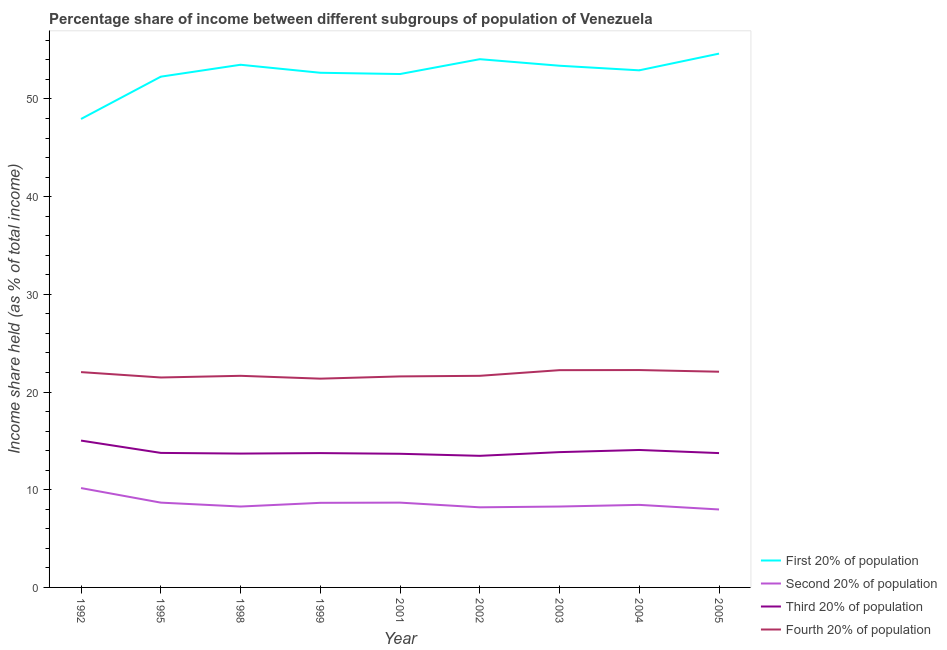How many different coloured lines are there?
Make the answer very short. 4. Does the line corresponding to share of the income held by second 20% of the population intersect with the line corresponding to share of the income held by fourth 20% of the population?
Ensure brevity in your answer.  No. What is the share of the income held by first 20% of the population in 1999?
Ensure brevity in your answer.  52.68. Across all years, what is the maximum share of the income held by fourth 20% of the population?
Ensure brevity in your answer.  22.25. Across all years, what is the minimum share of the income held by second 20% of the population?
Ensure brevity in your answer.  7.98. In which year was the share of the income held by fourth 20% of the population maximum?
Your answer should be compact. 2004. In which year was the share of the income held by fourth 20% of the population minimum?
Your answer should be very brief. 1999. What is the total share of the income held by second 20% of the population in the graph?
Make the answer very short. 77.38. What is the difference between the share of the income held by first 20% of the population in 1995 and that in 2003?
Provide a short and direct response. -1.12. What is the difference between the share of the income held by fourth 20% of the population in 1992 and the share of the income held by second 20% of the population in 2004?
Give a very brief answer. 13.59. What is the average share of the income held by first 20% of the population per year?
Keep it short and to the point. 52.67. In the year 2003, what is the difference between the share of the income held by second 20% of the population and share of the income held by first 20% of the population?
Provide a short and direct response. -45.12. In how many years, is the share of the income held by second 20% of the population greater than 34 %?
Offer a very short reply. 0. What is the ratio of the share of the income held by first 20% of the population in 2001 to that in 2003?
Offer a terse response. 0.98. What is the difference between the highest and the second highest share of the income held by first 20% of the population?
Your answer should be compact. 0.57. What is the difference between the highest and the lowest share of the income held by first 20% of the population?
Ensure brevity in your answer.  6.69. Is it the case that in every year, the sum of the share of the income held by first 20% of the population and share of the income held by fourth 20% of the population is greater than the sum of share of the income held by second 20% of the population and share of the income held by third 20% of the population?
Your answer should be very brief. Yes. Does the share of the income held by first 20% of the population monotonically increase over the years?
Your answer should be compact. No. Is the share of the income held by third 20% of the population strictly greater than the share of the income held by first 20% of the population over the years?
Your response must be concise. No. What is the difference between two consecutive major ticks on the Y-axis?
Ensure brevity in your answer.  10. Are the values on the major ticks of Y-axis written in scientific E-notation?
Your response must be concise. No. How are the legend labels stacked?
Provide a short and direct response. Vertical. What is the title of the graph?
Your answer should be very brief. Percentage share of income between different subgroups of population of Venezuela. Does "PFC gas" appear as one of the legend labels in the graph?
Your response must be concise. No. What is the label or title of the X-axis?
Your answer should be very brief. Year. What is the label or title of the Y-axis?
Offer a very short reply. Income share held (as % of total income). What is the Income share held (as % of total income) in First 20% of population in 1992?
Keep it short and to the point. 47.95. What is the Income share held (as % of total income) of Second 20% of population in 1992?
Your response must be concise. 10.17. What is the Income share held (as % of total income) of Third 20% of population in 1992?
Provide a succinct answer. 15.03. What is the Income share held (as % of total income) of Fourth 20% of population in 1992?
Keep it short and to the point. 22.04. What is the Income share held (as % of total income) in First 20% of population in 1995?
Offer a terse response. 52.28. What is the Income share held (as % of total income) of Second 20% of population in 1995?
Keep it short and to the point. 8.68. What is the Income share held (as % of total income) in Third 20% of population in 1995?
Provide a short and direct response. 13.77. What is the Income share held (as % of total income) of Fourth 20% of population in 1995?
Offer a very short reply. 21.49. What is the Income share held (as % of total income) of First 20% of population in 1998?
Your answer should be compact. 53.5. What is the Income share held (as % of total income) in Second 20% of population in 1998?
Make the answer very short. 8.28. What is the Income share held (as % of total income) of Third 20% of population in 1998?
Your response must be concise. 13.7. What is the Income share held (as % of total income) in Fourth 20% of population in 1998?
Keep it short and to the point. 21.66. What is the Income share held (as % of total income) of First 20% of population in 1999?
Give a very brief answer. 52.68. What is the Income share held (as % of total income) in Second 20% of population in 1999?
Provide a short and direct response. 8.66. What is the Income share held (as % of total income) in Third 20% of population in 1999?
Your response must be concise. 13.75. What is the Income share held (as % of total income) in Fourth 20% of population in 1999?
Provide a succinct answer. 21.37. What is the Income share held (as % of total income) in First 20% of population in 2001?
Your answer should be very brief. 52.55. What is the Income share held (as % of total income) in Second 20% of population in 2001?
Provide a succinct answer. 8.68. What is the Income share held (as % of total income) in Third 20% of population in 2001?
Your answer should be very brief. 13.68. What is the Income share held (as % of total income) in Fourth 20% of population in 2001?
Keep it short and to the point. 21.6. What is the Income share held (as % of total income) in First 20% of population in 2002?
Make the answer very short. 54.07. What is the Income share held (as % of total income) of Second 20% of population in 2002?
Your response must be concise. 8.2. What is the Income share held (as % of total income) of Third 20% of population in 2002?
Your response must be concise. 13.47. What is the Income share held (as % of total income) of Fourth 20% of population in 2002?
Provide a succinct answer. 21.66. What is the Income share held (as % of total income) in First 20% of population in 2003?
Your answer should be compact. 53.4. What is the Income share held (as % of total income) of Second 20% of population in 2003?
Your answer should be very brief. 8.28. What is the Income share held (as % of total income) of Third 20% of population in 2003?
Give a very brief answer. 13.85. What is the Income share held (as % of total income) of Fourth 20% of population in 2003?
Your response must be concise. 22.24. What is the Income share held (as % of total income) in First 20% of population in 2004?
Offer a terse response. 52.93. What is the Income share held (as % of total income) in Second 20% of population in 2004?
Your answer should be very brief. 8.45. What is the Income share held (as % of total income) of Third 20% of population in 2004?
Your answer should be very brief. 14.07. What is the Income share held (as % of total income) in Fourth 20% of population in 2004?
Ensure brevity in your answer.  22.25. What is the Income share held (as % of total income) of First 20% of population in 2005?
Offer a terse response. 54.64. What is the Income share held (as % of total income) in Second 20% of population in 2005?
Offer a very short reply. 7.98. What is the Income share held (as % of total income) in Third 20% of population in 2005?
Your answer should be very brief. 13.75. What is the Income share held (as % of total income) of Fourth 20% of population in 2005?
Ensure brevity in your answer.  22.08. Across all years, what is the maximum Income share held (as % of total income) in First 20% of population?
Your answer should be very brief. 54.64. Across all years, what is the maximum Income share held (as % of total income) in Second 20% of population?
Your response must be concise. 10.17. Across all years, what is the maximum Income share held (as % of total income) in Third 20% of population?
Your answer should be very brief. 15.03. Across all years, what is the maximum Income share held (as % of total income) of Fourth 20% of population?
Give a very brief answer. 22.25. Across all years, what is the minimum Income share held (as % of total income) in First 20% of population?
Keep it short and to the point. 47.95. Across all years, what is the minimum Income share held (as % of total income) of Second 20% of population?
Your answer should be very brief. 7.98. Across all years, what is the minimum Income share held (as % of total income) in Third 20% of population?
Provide a short and direct response. 13.47. Across all years, what is the minimum Income share held (as % of total income) in Fourth 20% of population?
Ensure brevity in your answer.  21.37. What is the total Income share held (as % of total income) in First 20% of population in the graph?
Offer a terse response. 474. What is the total Income share held (as % of total income) of Second 20% of population in the graph?
Your response must be concise. 77.38. What is the total Income share held (as % of total income) of Third 20% of population in the graph?
Provide a succinct answer. 125.07. What is the total Income share held (as % of total income) in Fourth 20% of population in the graph?
Provide a succinct answer. 196.39. What is the difference between the Income share held (as % of total income) of First 20% of population in 1992 and that in 1995?
Your response must be concise. -4.33. What is the difference between the Income share held (as % of total income) of Second 20% of population in 1992 and that in 1995?
Give a very brief answer. 1.49. What is the difference between the Income share held (as % of total income) in Third 20% of population in 1992 and that in 1995?
Offer a terse response. 1.26. What is the difference between the Income share held (as % of total income) in Fourth 20% of population in 1992 and that in 1995?
Give a very brief answer. 0.55. What is the difference between the Income share held (as % of total income) in First 20% of population in 1992 and that in 1998?
Make the answer very short. -5.55. What is the difference between the Income share held (as % of total income) of Second 20% of population in 1992 and that in 1998?
Provide a succinct answer. 1.89. What is the difference between the Income share held (as % of total income) of Third 20% of population in 1992 and that in 1998?
Keep it short and to the point. 1.33. What is the difference between the Income share held (as % of total income) in Fourth 20% of population in 1992 and that in 1998?
Provide a succinct answer. 0.38. What is the difference between the Income share held (as % of total income) of First 20% of population in 1992 and that in 1999?
Provide a succinct answer. -4.73. What is the difference between the Income share held (as % of total income) of Second 20% of population in 1992 and that in 1999?
Your response must be concise. 1.51. What is the difference between the Income share held (as % of total income) in Third 20% of population in 1992 and that in 1999?
Your answer should be very brief. 1.28. What is the difference between the Income share held (as % of total income) of Fourth 20% of population in 1992 and that in 1999?
Give a very brief answer. 0.67. What is the difference between the Income share held (as % of total income) of First 20% of population in 1992 and that in 2001?
Provide a short and direct response. -4.6. What is the difference between the Income share held (as % of total income) in Second 20% of population in 1992 and that in 2001?
Provide a short and direct response. 1.49. What is the difference between the Income share held (as % of total income) of Third 20% of population in 1992 and that in 2001?
Make the answer very short. 1.35. What is the difference between the Income share held (as % of total income) in Fourth 20% of population in 1992 and that in 2001?
Ensure brevity in your answer.  0.44. What is the difference between the Income share held (as % of total income) of First 20% of population in 1992 and that in 2002?
Your answer should be very brief. -6.12. What is the difference between the Income share held (as % of total income) of Second 20% of population in 1992 and that in 2002?
Offer a very short reply. 1.97. What is the difference between the Income share held (as % of total income) in Third 20% of population in 1992 and that in 2002?
Your answer should be compact. 1.56. What is the difference between the Income share held (as % of total income) of Fourth 20% of population in 1992 and that in 2002?
Provide a short and direct response. 0.38. What is the difference between the Income share held (as % of total income) of First 20% of population in 1992 and that in 2003?
Make the answer very short. -5.45. What is the difference between the Income share held (as % of total income) of Second 20% of population in 1992 and that in 2003?
Offer a very short reply. 1.89. What is the difference between the Income share held (as % of total income) in Third 20% of population in 1992 and that in 2003?
Offer a terse response. 1.18. What is the difference between the Income share held (as % of total income) of First 20% of population in 1992 and that in 2004?
Ensure brevity in your answer.  -4.98. What is the difference between the Income share held (as % of total income) of Second 20% of population in 1992 and that in 2004?
Offer a terse response. 1.72. What is the difference between the Income share held (as % of total income) in Fourth 20% of population in 1992 and that in 2004?
Give a very brief answer. -0.21. What is the difference between the Income share held (as % of total income) of First 20% of population in 1992 and that in 2005?
Provide a short and direct response. -6.69. What is the difference between the Income share held (as % of total income) in Second 20% of population in 1992 and that in 2005?
Your response must be concise. 2.19. What is the difference between the Income share held (as % of total income) in Third 20% of population in 1992 and that in 2005?
Offer a very short reply. 1.28. What is the difference between the Income share held (as % of total income) in Fourth 20% of population in 1992 and that in 2005?
Offer a very short reply. -0.04. What is the difference between the Income share held (as % of total income) in First 20% of population in 1995 and that in 1998?
Offer a terse response. -1.22. What is the difference between the Income share held (as % of total income) of Third 20% of population in 1995 and that in 1998?
Offer a very short reply. 0.07. What is the difference between the Income share held (as % of total income) of Fourth 20% of population in 1995 and that in 1998?
Your answer should be compact. -0.17. What is the difference between the Income share held (as % of total income) of First 20% of population in 1995 and that in 1999?
Offer a terse response. -0.4. What is the difference between the Income share held (as % of total income) of Third 20% of population in 1995 and that in 1999?
Your answer should be compact. 0.02. What is the difference between the Income share held (as % of total income) of Fourth 20% of population in 1995 and that in 1999?
Ensure brevity in your answer.  0.12. What is the difference between the Income share held (as % of total income) of First 20% of population in 1995 and that in 2001?
Make the answer very short. -0.27. What is the difference between the Income share held (as % of total income) in Third 20% of population in 1995 and that in 2001?
Offer a very short reply. 0.09. What is the difference between the Income share held (as % of total income) of Fourth 20% of population in 1995 and that in 2001?
Offer a very short reply. -0.11. What is the difference between the Income share held (as % of total income) in First 20% of population in 1995 and that in 2002?
Keep it short and to the point. -1.79. What is the difference between the Income share held (as % of total income) of Second 20% of population in 1995 and that in 2002?
Give a very brief answer. 0.48. What is the difference between the Income share held (as % of total income) of Third 20% of population in 1995 and that in 2002?
Your answer should be very brief. 0.3. What is the difference between the Income share held (as % of total income) of Fourth 20% of population in 1995 and that in 2002?
Offer a very short reply. -0.17. What is the difference between the Income share held (as % of total income) in First 20% of population in 1995 and that in 2003?
Your answer should be compact. -1.12. What is the difference between the Income share held (as % of total income) in Third 20% of population in 1995 and that in 2003?
Make the answer very short. -0.08. What is the difference between the Income share held (as % of total income) of Fourth 20% of population in 1995 and that in 2003?
Offer a terse response. -0.75. What is the difference between the Income share held (as % of total income) in First 20% of population in 1995 and that in 2004?
Ensure brevity in your answer.  -0.65. What is the difference between the Income share held (as % of total income) of Second 20% of population in 1995 and that in 2004?
Provide a succinct answer. 0.23. What is the difference between the Income share held (as % of total income) in Third 20% of population in 1995 and that in 2004?
Keep it short and to the point. -0.3. What is the difference between the Income share held (as % of total income) of Fourth 20% of population in 1995 and that in 2004?
Give a very brief answer. -0.76. What is the difference between the Income share held (as % of total income) of First 20% of population in 1995 and that in 2005?
Offer a terse response. -2.36. What is the difference between the Income share held (as % of total income) of Fourth 20% of population in 1995 and that in 2005?
Your answer should be compact. -0.59. What is the difference between the Income share held (as % of total income) of First 20% of population in 1998 and that in 1999?
Ensure brevity in your answer.  0.82. What is the difference between the Income share held (as % of total income) in Second 20% of population in 1998 and that in 1999?
Offer a terse response. -0.38. What is the difference between the Income share held (as % of total income) in Third 20% of population in 1998 and that in 1999?
Give a very brief answer. -0.05. What is the difference between the Income share held (as % of total income) of Fourth 20% of population in 1998 and that in 1999?
Your response must be concise. 0.29. What is the difference between the Income share held (as % of total income) in First 20% of population in 1998 and that in 2001?
Your answer should be very brief. 0.95. What is the difference between the Income share held (as % of total income) of Second 20% of population in 1998 and that in 2001?
Ensure brevity in your answer.  -0.4. What is the difference between the Income share held (as % of total income) in Third 20% of population in 1998 and that in 2001?
Provide a succinct answer. 0.02. What is the difference between the Income share held (as % of total income) in First 20% of population in 1998 and that in 2002?
Offer a terse response. -0.57. What is the difference between the Income share held (as % of total income) of Second 20% of population in 1998 and that in 2002?
Your answer should be compact. 0.08. What is the difference between the Income share held (as % of total income) of Third 20% of population in 1998 and that in 2002?
Your answer should be very brief. 0.23. What is the difference between the Income share held (as % of total income) of Third 20% of population in 1998 and that in 2003?
Give a very brief answer. -0.15. What is the difference between the Income share held (as % of total income) in Fourth 20% of population in 1998 and that in 2003?
Keep it short and to the point. -0.58. What is the difference between the Income share held (as % of total income) of First 20% of population in 1998 and that in 2004?
Provide a succinct answer. 0.57. What is the difference between the Income share held (as % of total income) in Second 20% of population in 1998 and that in 2004?
Offer a terse response. -0.17. What is the difference between the Income share held (as % of total income) of Third 20% of population in 1998 and that in 2004?
Offer a terse response. -0.37. What is the difference between the Income share held (as % of total income) in Fourth 20% of population in 1998 and that in 2004?
Keep it short and to the point. -0.59. What is the difference between the Income share held (as % of total income) in First 20% of population in 1998 and that in 2005?
Offer a very short reply. -1.14. What is the difference between the Income share held (as % of total income) in Second 20% of population in 1998 and that in 2005?
Provide a succinct answer. 0.3. What is the difference between the Income share held (as % of total income) in Third 20% of population in 1998 and that in 2005?
Give a very brief answer. -0.05. What is the difference between the Income share held (as % of total income) of Fourth 20% of population in 1998 and that in 2005?
Your response must be concise. -0.42. What is the difference between the Income share held (as % of total income) of First 20% of population in 1999 and that in 2001?
Your answer should be very brief. 0.13. What is the difference between the Income share held (as % of total income) in Second 20% of population in 1999 and that in 2001?
Make the answer very short. -0.02. What is the difference between the Income share held (as % of total income) of Third 20% of population in 1999 and that in 2001?
Keep it short and to the point. 0.07. What is the difference between the Income share held (as % of total income) of Fourth 20% of population in 1999 and that in 2001?
Give a very brief answer. -0.23. What is the difference between the Income share held (as % of total income) of First 20% of population in 1999 and that in 2002?
Your answer should be compact. -1.39. What is the difference between the Income share held (as % of total income) in Second 20% of population in 1999 and that in 2002?
Provide a short and direct response. 0.46. What is the difference between the Income share held (as % of total income) in Third 20% of population in 1999 and that in 2002?
Make the answer very short. 0.28. What is the difference between the Income share held (as % of total income) of Fourth 20% of population in 1999 and that in 2002?
Your answer should be very brief. -0.29. What is the difference between the Income share held (as % of total income) in First 20% of population in 1999 and that in 2003?
Provide a short and direct response. -0.72. What is the difference between the Income share held (as % of total income) of Second 20% of population in 1999 and that in 2003?
Your answer should be compact. 0.38. What is the difference between the Income share held (as % of total income) of Fourth 20% of population in 1999 and that in 2003?
Ensure brevity in your answer.  -0.87. What is the difference between the Income share held (as % of total income) of First 20% of population in 1999 and that in 2004?
Your response must be concise. -0.25. What is the difference between the Income share held (as % of total income) of Second 20% of population in 1999 and that in 2004?
Give a very brief answer. 0.21. What is the difference between the Income share held (as % of total income) of Third 20% of population in 1999 and that in 2004?
Make the answer very short. -0.32. What is the difference between the Income share held (as % of total income) in Fourth 20% of population in 1999 and that in 2004?
Provide a short and direct response. -0.88. What is the difference between the Income share held (as % of total income) of First 20% of population in 1999 and that in 2005?
Give a very brief answer. -1.96. What is the difference between the Income share held (as % of total income) in Second 20% of population in 1999 and that in 2005?
Provide a short and direct response. 0.68. What is the difference between the Income share held (as % of total income) in Third 20% of population in 1999 and that in 2005?
Give a very brief answer. 0. What is the difference between the Income share held (as % of total income) of Fourth 20% of population in 1999 and that in 2005?
Offer a terse response. -0.71. What is the difference between the Income share held (as % of total income) in First 20% of population in 2001 and that in 2002?
Provide a short and direct response. -1.52. What is the difference between the Income share held (as % of total income) of Second 20% of population in 2001 and that in 2002?
Provide a succinct answer. 0.48. What is the difference between the Income share held (as % of total income) in Third 20% of population in 2001 and that in 2002?
Make the answer very short. 0.21. What is the difference between the Income share held (as % of total income) of Fourth 20% of population in 2001 and that in 2002?
Offer a terse response. -0.06. What is the difference between the Income share held (as % of total income) in First 20% of population in 2001 and that in 2003?
Give a very brief answer. -0.85. What is the difference between the Income share held (as % of total income) in Second 20% of population in 2001 and that in 2003?
Your answer should be compact. 0.4. What is the difference between the Income share held (as % of total income) of Third 20% of population in 2001 and that in 2003?
Ensure brevity in your answer.  -0.17. What is the difference between the Income share held (as % of total income) in Fourth 20% of population in 2001 and that in 2003?
Your answer should be compact. -0.64. What is the difference between the Income share held (as % of total income) in First 20% of population in 2001 and that in 2004?
Provide a succinct answer. -0.38. What is the difference between the Income share held (as % of total income) in Second 20% of population in 2001 and that in 2004?
Keep it short and to the point. 0.23. What is the difference between the Income share held (as % of total income) in Third 20% of population in 2001 and that in 2004?
Your response must be concise. -0.39. What is the difference between the Income share held (as % of total income) in Fourth 20% of population in 2001 and that in 2004?
Your answer should be compact. -0.65. What is the difference between the Income share held (as % of total income) of First 20% of population in 2001 and that in 2005?
Offer a terse response. -2.09. What is the difference between the Income share held (as % of total income) in Third 20% of population in 2001 and that in 2005?
Offer a very short reply. -0.07. What is the difference between the Income share held (as % of total income) of Fourth 20% of population in 2001 and that in 2005?
Your answer should be compact. -0.48. What is the difference between the Income share held (as % of total income) in First 20% of population in 2002 and that in 2003?
Keep it short and to the point. 0.67. What is the difference between the Income share held (as % of total income) of Second 20% of population in 2002 and that in 2003?
Give a very brief answer. -0.08. What is the difference between the Income share held (as % of total income) of Third 20% of population in 2002 and that in 2003?
Your response must be concise. -0.38. What is the difference between the Income share held (as % of total income) of Fourth 20% of population in 2002 and that in 2003?
Provide a succinct answer. -0.58. What is the difference between the Income share held (as % of total income) in First 20% of population in 2002 and that in 2004?
Offer a terse response. 1.14. What is the difference between the Income share held (as % of total income) in Third 20% of population in 2002 and that in 2004?
Provide a short and direct response. -0.6. What is the difference between the Income share held (as % of total income) in Fourth 20% of population in 2002 and that in 2004?
Provide a short and direct response. -0.59. What is the difference between the Income share held (as % of total income) of First 20% of population in 2002 and that in 2005?
Provide a succinct answer. -0.57. What is the difference between the Income share held (as % of total income) in Second 20% of population in 2002 and that in 2005?
Offer a very short reply. 0.22. What is the difference between the Income share held (as % of total income) in Third 20% of population in 2002 and that in 2005?
Give a very brief answer. -0.28. What is the difference between the Income share held (as % of total income) in Fourth 20% of population in 2002 and that in 2005?
Provide a succinct answer. -0.42. What is the difference between the Income share held (as % of total income) in First 20% of population in 2003 and that in 2004?
Offer a terse response. 0.47. What is the difference between the Income share held (as % of total income) in Second 20% of population in 2003 and that in 2004?
Your answer should be compact. -0.17. What is the difference between the Income share held (as % of total income) in Third 20% of population in 2003 and that in 2004?
Provide a short and direct response. -0.22. What is the difference between the Income share held (as % of total income) in Fourth 20% of population in 2003 and that in 2004?
Your response must be concise. -0.01. What is the difference between the Income share held (as % of total income) in First 20% of population in 2003 and that in 2005?
Ensure brevity in your answer.  -1.24. What is the difference between the Income share held (as % of total income) in Fourth 20% of population in 2003 and that in 2005?
Provide a short and direct response. 0.16. What is the difference between the Income share held (as % of total income) in First 20% of population in 2004 and that in 2005?
Your answer should be very brief. -1.71. What is the difference between the Income share held (as % of total income) of Second 20% of population in 2004 and that in 2005?
Ensure brevity in your answer.  0.47. What is the difference between the Income share held (as % of total income) in Third 20% of population in 2004 and that in 2005?
Provide a succinct answer. 0.32. What is the difference between the Income share held (as % of total income) of Fourth 20% of population in 2004 and that in 2005?
Offer a terse response. 0.17. What is the difference between the Income share held (as % of total income) of First 20% of population in 1992 and the Income share held (as % of total income) of Second 20% of population in 1995?
Make the answer very short. 39.27. What is the difference between the Income share held (as % of total income) in First 20% of population in 1992 and the Income share held (as % of total income) in Third 20% of population in 1995?
Offer a terse response. 34.18. What is the difference between the Income share held (as % of total income) in First 20% of population in 1992 and the Income share held (as % of total income) in Fourth 20% of population in 1995?
Provide a short and direct response. 26.46. What is the difference between the Income share held (as % of total income) in Second 20% of population in 1992 and the Income share held (as % of total income) in Fourth 20% of population in 1995?
Offer a very short reply. -11.32. What is the difference between the Income share held (as % of total income) of Third 20% of population in 1992 and the Income share held (as % of total income) of Fourth 20% of population in 1995?
Your answer should be compact. -6.46. What is the difference between the Income share held (as % of total income) of First 20% of population in 1992 and the Income share held (as % of total income) of Second 20% of population in 1998?
Make the answer very short. 39.67. What is the difference between the Income share held (as % of total income) of First 20% of population in 1992 and the Income share held (as % of total income) of Third 20% of population in 1998?
Keep it short and to the point. 34.25. What is the difference between the Income share held (as % of total income) in First 20% of population in 1992 and the Income share held (as % of total income) in Fourth 20% of population in 1998?
Provide a short and direct response. 26.29. What is the difference between the Income share held (as % of total income) in Second 20% of population in 1992 and the Income share held (as % of total income) in Third 20% of population in 1998?
Keep it short and to the point. -3.53. What is the difference between the Income share held (as % of total income) of Second 20% of population in 1992 and the Income share held (as % of total income) of Fourth 20% of population in 1998?
Ensure brevity in your answer.  -11.49. What is the difference between the Income share held (as % of total income) of Third 20% of population in 1992 and the Income share held (as % of total income) of Fourth 20% of population in 1998?
Keep it short and to the point. -6.63. What is the difference between the Income share held (as % of total income) in First 20% of population in 1992 and the Income share held (as % of total income) in Second 20% of population in 1999?
Ensure brevity in your answer.  39.29. What is the difference between the Income share held (as % of total income) in First 20% of population in 1992 and the Income share held (as % of total income) in Third 20% of population in 1999?
Offer a terse response. 34.2. What is the difference between the Income share held (as % of total income) in First 20% of population in 1992 and the Income share held (as % of total income) in Fourth 20% of population in 1999?
Ensure brevity in your answer.  26.58. What is the difference between the Income share held (as % of total income) in Second 20% of population in 1992 and the Income share held (as % of total income) in Third 20% of population in 1999?
Your answer should be very brief. -3.58. What is the difference between the Income share held (as % of total income) of Second 20% of population in 1992 and the Income share held (as % of total income) of Fourth 20% of population in 1999?
Keep it short and to the point. -11.2. What is the difference between the Income share held (as % of total income) of Third 20% of population in 1992 and the Income share held (as % of total income) of Fourth 20% of population in 1999?
Offer a terse response. -6.34. What is the difference between the Income share held (as % of total income) in First 20% of population in 1992 and the Income share held (as % of total income) in Second 20% of population in 2001?
Offer a terse response. 39.27. What is the difference between the Income share held (as % of total income) in First 20% of population in 1992 and the Income share held (as % of total income) in Third 20% of population in 2001?
Ensure brevity in your answer.  34.27. What is the difference between the Income share held (as % of total income) of First 20% of population in 1992 and the Income share held (as % of total income) of Fourth 20% of population in 2001?
Give a very brief answer. 26.35. What is the difference between the Income share held (as % of total income) of Second 20% of population in 1992 and the Income share held (as % of total income) of Third 20% of population in 2001?
Your response must be concise. -3.51. What is the difference between the Income share held (as % of total income) in Second 20% of population in 1992 and the Income share held (as % of total income) in Fourth 20% of population in 2001?
Keep it short and to the point. -11.43. What is the difference between the Income share held (as % of total income) of Third 20% of population in 1992 and the Income share held (as % of total income) of Fourth 20% of population in 2001?
Your answer should be very brief. -6.57. What is the difference between the Income share held (as % of total income) in First 20% of population in 1992 and the Income share held (as % of total income) in Second 20% of population in 2002?
Ensure brevity in your answer.  39.75. What is the difference between the Income share held (as % of total income) in First 20% of population in 1992 and the Income share held (as % of total income) in Third 20% of population in 2002?
Ensure brevity in your answer.  34.48. What is the difference between the Income share held (as % of total income) in First 20% of population in 1992 and the Income share held (as % of total income) in Fourth 20% of population in 2002?
Provide a short and direct response. 26.29. What is the difference between the Income share held (as % of total income) in Second 20% of population in 1992 and the Income share held (as % of total income) in Third 20% of population in 2002?
Give a very brief answer. -3.3. What is the difference between the Income share held (as % of total income) in Second 20% of population in 1992 and the Income share held (as % of total income) in Fourth 20% of population in 2002?
Offer a very short reply. -11.49. What is the difference between the Income share held (as % of total income) of Third 20% of population in 1992 and the Income share held (as % of total income) of Fourth 20% of population in 2002?
Provide a succinct answer. -6.63. What is the difference between the Income share held (as % of total income) of First 20% of population in 1992 and the Income share held (as % of total income) of Second 20% of population in 2003?
Provide a succinct answer. 39.67. What is the difference between the Income share held (as % of total income) of First 20% of population in 1992 and the Income share held (as % of total income) of Third 20% of population in 2003?
Your response must be concise. 34.1. What is the difference between the Income share held (as % of total income) of First 20% of population in 1992 and the Income share held (as % of total income) of Fourth 20% of population in 2003?
Your answer should be very brief. 25.71. What is the difference between the Income share held (as % of total income) of Second 20% of population in 1992 and the Income share held (as % of total income) of Third 20% of population in 2003?
Your answer should be very brief. -3.68. What is the difference between the Income share held (as % of total income) in Second 20% of population in 1992 and the Income share held (as % of total income) in Fourth 20% of population in 2003?
Your answer should be compact. -12.07. What is the difference between the Income share held (as % of total income) in Third 20% of population in 1992 and the Income share held (as % of total income) in Fourth 20% of population in 2003?
Ensure brevity in your answer.  -7.21. What is the difference between the Income share held (as % of total income) in First 20% of population in 1992 and the Income share held (as % of total income) in Second 20% of population in 2004?
Offer a very short reply. 39.5. What is the difference between the Income share held (as % of total income) in First 20% of population in 1992 and the Income share held (as % of total income) in Third 20% of population in 2004?
Keep it short and to the point. 33.88. What is the difference between the Income share held (as % of total income) in First 20% of population in 1992 and the Income share held (as % of total income) in Fourth 20% of population in 2004?
Make the answer very short. 25.7. What is the difference between the Income share held (as % of total income) in Second 20% of population in 1992 and the Income share held (as % of total income) in Third 20% of population in 2004?
Keep it short and to the point. -3.9. What is the difference between the Income share held (as % of total income) in Second 20% of population in 1992 and the Income share held (as % of total income) in Fourth 20% of population in 2004?
Your answer should be compact. -12.08. What is the difference between the Income share held (as % of total income) in Third 20% of population in 1992 and the Income share held (as % of total income) in Fourth 20% of population in 2004?
Your answer should be very brief. -7.22. What is the difference between the Income share held (as % of total income) of First 20% of population in 1992 and the Income share held (as % of total income) of Second 20% of population in 2005?
Your answer should be compact. 39.97. What is the difference between the Income share held (as % of total income) in First 20% of population in 1992 and the Income share held (as % of total income) in Third 20% of population in 2005?
Offer a terse response. 34.2. What is the difference between the Income share held (as % of total income) in First 20% of population in 1992 and the Income share held (as % of total income) in Fourth 20% of population in 2005?
Keep it short and to the point. 25.87. What is the difference between the Income share held (as % of total income) in Second 20% of population in 1992 and the Income share held (as % of total income) in Third 20% of population in 2005?
Give a very brief answer. -3.58. What is the difference between the Income share held (as % of total income) in Second 20% of population in 1992 and the Income share held (as % of total income) in Fourth 20% of population in 2005?
Your answer should be compact. -11.91. What is the difference between the Income share held (as % of total income) in Third 20% of population in 1992 and the Income share held (as % of total income) in Fourth 20% of population in 2005?
Ensure brevity in your answer.  -7.05. What is the difference between the Income share held (as % of total income) in First 20% of population in 1995 and the Income share held (as % of total income) in Second 20% of population in 1998?
Make the answer very short. 44. What is the difference between the Income share held (as % of total income) of First 20% of population in 1995 and the Income share held (as % of total income) of Third 20% of population in 1998?
Offer a terse response. 38.58. What is the difference between the Income share held (as % of total income) of First 20% of population in 1995 and the Income share held (as % of total income) of Fourth 20% of population in 1998?
Make the answer very short. 30.62. What is the difference between the Income share held (as % of total income) of Second 20% of population in 1995 and the Income share held (as % of total income) of Third 20% of population in 1998?
Give a very brief answer. -5.02. What is the difference between the Income share held (as % of total income) in Second 20% of population in 1995 and the Income share held (as % of total income) in Fourth 20% of population in 1998?
Offer a very short reply. -12.98. What is the difference between the Income share held (as % of total income) of Third 20% of population in 1995 and the Income share held (as % of total income) of Fourth 20% of population in 1998?
Ensure brevity in your answer.  -7.89. What is the difference between the Income share held (as % of total income) of First 20% of population in 1995 and the Income share held (as % of total income) of Second 20% of population in 1999?
Keep it short and to the point. 43.62. What is the difference between the Income share held (as % of total income) of First 20% of population in 1995 and the Income share held (as % of total income) of Third 20% of population in 1999?
Offer a very short reply. 38.53. What is the difference between the Income share held (as % of total income) of First 20% of population in 1995 and the Income share held (as % of total income) of Fourth 20% of population in 1999?
Give a very brief answer. 30.91. What is the difference between the Income share held (as % of total income) in Second 20% of population in 1995 and the Income share held (as % of total income) in Third 20% of population in 1999?
Give a very brief answer. -5.07. What is the difference between the Income share held (as % of total income) of Second 20% of population in 1995 and the Income share held (as % of total income) of Fourth 20% of population in 1999?
Give a very brief answer. -12.69. What is the difference between the Income share held (as % of total income) in First 20% of population in 1995 and the Income share held (as % of total income) in Second 20% of population in 2001?
Your response must be concise. 43.6. What is the difference between the Income share held (as % of total income) in First 20% of population in 1995 and the Income share held (as % of total income) in Third 20% of population in 2001?
Give a very brief answer. 38.6. What is the difference between the Income share held (as % of total income) of First 20% of population in 1995 and the Income share held (as % of total income) of Fourth 20% of population in 2001?
Make the answer very short. 30.68. What is the difference between the Income share held (as % of total income) in Second 20% of population in 1995 and the Income share held (as % of total income) in Fourth 20% of population in 2001?
Offer a very short reply. -12.92. What is the difference between the Income share held (as % of total income) in Third 20% of population in 1995 and the Income share held (as % of total income) in Fourth 20% of population in 2001?
Provide a short and direct response. -7.83. What is the difference between the Income share held (as % of total income) of First 20% of population in 1995 and the Income share held (as % of total income) of Second 20% of population in 2002?
Make the answer very short. 44.08. What is the difference between the Income share held (as % of total income) in First 20% of population in 1995 and the Income share held (as % of total income) in Third 20% of population in 2002?
Give a very brief answer. 38.81. What is the difference between the Income share held (as % of total income) of First 20% of population in 1995 and the Income share held (as % of total income) of Fourth 20% of population in 2002?
Provide a succinct answer. 30.62. What is the difference between the Income share held (as % of total income) in Second 20% of population in 1995 and the Income share held (as % of total income) in Third 20% of population in 2002?
Provide a succinct answer. -4.79. What is the difference between the Income share held (as % of total income) in Second 20% of population in 1995 and the Income share held (as % of total income) in Fourth 20% of population in 2002?
Provide a succinct answer. -12.98. What is the difference between the Income share held (as % of total income) of Third 20% of population in 1995 and the Income share held (as % of total income) of Fourth 20% of population in 2002?
Ensure brevity in your answer.  -7.89. What is the difference between the Income share held (as % of total income) in First 20% of population in 1995 and the Income share held (as % of total income) in Second 20% of population in 2003?
Make the answer very short. 44. What is the difference between the Income share held (as % of total income) in First 20% of population in 1995 and the Income share held (as % of total income) in Third 20% of population in 2003?
Ensure brevity in your answer.  38.43. What is the difference between the Income share held (as % of total income) of First 20% of population in 1995 and the Income share held (as % of total income) of Fourth 20% of population in 2003?
Keep it short and to the point. 30.04. What is the difference between the Income share held (as % of total income) in Second 20% of population in 1995 and the Income share held (as % of total income) in Third 20% of population in 2003?
Keep it short and to the point. -5.17. What is the difference between the Income share held (as % of total income) in Second 20% of population in 1995 and the Income share held (as % of total income) in Fourth 20% of population in 2003?
Your answer should be compact. -13.56. What is the difference between the Income share held (as % of total income) of Third 20% of population in 1995 and the Income share held (as % of total income) of Fourth 20% of population in 2003?
Provide a succinct answer. -8.47. What is the difference between the Income share held (as % of total income) in First 20% of population in 1995 and the Income share held (as % of total income) in Second 20% of population in 2004?
Give a very brief answer. 43.83. What is the difference between the Income share held (as % of total income) in First 20% of population in 1995 and the Income share held (as % of total income) in Third 20% of population in 2004?
Offer a terse response. 38.21. What is the difference between the Income share held (as % of total income) of First 20% of population in 1995 and the Income share held (as % of total income) of Fourth 20% of population in 2004?
Your response must be concise. 30.03. What is the difference between the Income share held (as % of total income) of Second 20% of population in 1995 and the Income share held (as % of total income) of Third 20% of population in 2004?
Provide a succinct answer. -5.39. What is the difference between the Income share held (as % of total income) of Second 20% of population in 1995 and the Income share held (as % of total income) of Fourth 20% of population in 2004?
Make the answer very short. -13.57. What is the difference between the Income share held (as % of total income) in Third 20% of population in 1995 and the Income share held (as % of total income) in Fourth 20% of population in 2004?
Your answer should be compact. -8.48. What is the difference between the Income share held (as % of total income) in First 20% of population in 1995 and the Income share held (as % of total income) in Second 20% of population in 2005?
Keep it short and to the point. 44.3. What is the difference between the Income share held (as % of total income) of First 20% of population in 1995 and the Income share held (as % of total income) of Third 20% of population in 2005?
Make the answer very short. 38.53. What is the difference between the Income share held (as % of total income) in First 20% of population in 1995 and the Income share held (as % of total income) in Fourth 20% of population in 2005?
Ensure brevity in your answer.  30.2. What is the difference between the Income share held (as % of total income) of Second 20% of population in 1995 and the Income share held (as % of total income) of Third 20% of population in 2005?
Offer a terse response. -5.07. What is the difference between the Income share held (as % of total income) of Third 20% of population in 1995 and the Income share held (as % of total income) of Fourth 20% of population in 2005?
Your answer should be compact. -8.31. What is the difference between the Income share held (as % of total income) of First 20% of population in 1998 and the Income share held (as % of total income) of Second 20% of population in 1999?
Ensure brevity in your answer.  44.84. What is the difference between the Income share held (as % of total income) of First 20% of population in 1998 and the Income share held (as % of total income) of Third 20% of population in 1999?
Give a very brief answer. 39.75. What is the difference between the Income share held (as % of total income) of First 20% of population in 1998 and the Income share held (as % of total income) of Fourth 20% of population in 1999?
Give a very brief answer. 32.13. What is the difference between the Income share held (as % of total income) in Second 20% of population in 1998 and the Income share held (as % of total income) in Third 20% of population in 1999?
Offer a very short reply. -5.47. What is the difference between the Income share held (as % of total income) in Second 20% of population in 1998 and the Income share held (as % of total income) in Fourth 20% of population in 1999?
Make the answer very short. -13.09. What is the difference between the Income share held (as % of total income) of Third 20% of population in 1998 and the Income share held (as % of total income) of Fourth 20% of population in 1999?
Give a very brief answer. -7.67. What is the difference between the Income share held (as % of total income) in First 20% of population in 1998 and the Income share held (as % of total income) in Second 20% of population in 2001?
Keep it short and to the point. 44.82. What is the difference between the Income share held (as % of total income) of First 20% of population in 1998 and the Income share held (as % of total income) of Third 20% of population in 2001?
Your response must be concise. 39.82. What is the difference between the Income share held (as % of total income) in First 20% of population in 1998 and the Income share held (as % of total income) in Fourth 20% of population in 2001?
Keep it short and to the point. 31.9. What is the difference between the Income share held (as % of total income) in Second 20% of population in 1998 and the Income share held (as % of total income) in Fourth 20% of population in 2001?
Ensure brevity in your answer.  -13.32. What is the difference between the Income share held (as % of total income) in Third 20% of population in 1998 and the Income share held (as % of total income) in Fourth 20% of population in 2001?
Provide a short and direct response. -7.9. What is the difference between the Income share held (as % of total income) in First 20% of population in 1998 and the Income share held (as % of total income) in Second 20% of population in 2002?
Offer a terse response. 45.3. What is the difference between the Income share held (as % of total income) of First 20% of population in 1998 and the Income share held (as % of total income) of Third 20% of population in 2002?
Make the answer very short. 40.03. What is the difference between the Income share held (as % of total income) in First 20% of population in 1998 and the Income share held (as % of total income) in Fourth 20% of population in 2002?
Your answer should be very brief. 31.84. What is the difference between the Income share held (as % of total income) in Second 20% of population in 1998 and the Income share held (as % of total income) in Third 20% of population in 2002?
Keep it short and to the point. -5.19. What is the difference between the Income share held (as % of total income) of Second 20% of population in 1998 and the Income share held (as % of total income) of Fourth 20% of population in 2002?
Make the answer very short. -13.38. What is the difference between the Income share held (as % of total income) of Third 20% of population in 1998 and the Income share held (as % of total income) of Fourth 20% of population in 2002?
Your response must be concise. -7.96. What is the difference between the Income share held (as % of total income) in First 20% of population in 1998 and the Income share held (as % of total income) in Second 20% of population in 2003?
Keep it short and to the point. 45.22. What is the difference between the Income share held (as % of total income) in First 20% of population in 1998 and the Income share held (as % of total income) in Third 20% of population in 2003?
Give a very brief answer. 39.65. What is the difference between the Income share held (as % of total income) in First 20% of population in 1998 and the Income share held (as % of total income) in Fourth 20% of population in 2003?
Keep it short and to the point. 31.26. What is the difference between the Income share held (as % of total income) in Second 20% of population in 1998 and the Income share held (as % of total income) in Third 20% of population in 2003?
Provide a short and direct response. -5.57. What is the difference between the Income share held (as % of total income) in Second 20% of population in 1998 and the Income share held (as % of total income) in Fourth 20% of population in 2003?
Your response must be concise. -13.96. What is the difference between the Income share held (as % of total income) of Third 20% of population in 1998 and the Income share held (as % of total income) of Fourth 20% of population in 2003?
Ensure brevity in your answer.  -8.54. What is the difference between the Income share held (as % of total income) of First 20% of population in 1998 and the Income share held (as % of total income) of Second 20% of population in 2004?
Ensure brevity in your answer.  45.05. What is the difference between the Income share held (as % of total income) of First 20% of population in 1998 and the Income share held (as % of total income) of Third 20% of population in 2004?
Provide a short and direct response. 39.43. What is the difference between the Income share held (as % of total income) of First 20% of population in 1998 and the Income share held (as % of total income) of Fourth 20% of population in 2004?
Make the answer very short. 31.25. What is the difference between the Income share held (as % of total income) in Second 20% of population in 1998 and the Income share held (as % of total income) in Third 20% of population in 2004?
Your answer should be compact. -5.79. What is the difference between the Income share held (as % of total income) of Second 20% of population in 1998 and the Income share held (as % of total income) of Fourth 20% of population in 2004?
Your response must be concise. -13.97. What is the difference between the Income share held (as % of total income) of Third 20% of population in 1998 and the Income share held (as % of total income) of Fourth 20% of population in 2004?
Ensure brevity in your answer.  -8.55. What is the difference between the Income share held (as % of total income) of First 20% of population in 1998 and the Income share held (as % of total income) of Second 20% of population in 2005?
Keep it short and to the point. 45.52. What is the difference between the Income share held (as % of total income) of First 20% of population in 1998 and the Income share held (as % of total income) of Third 20% of population in 2005?
Provide a succinct answer. 39.75. What is the difference between the Income share held (as % of total income) in First 20% of population in 1998 and the Income share held (as % of total income) in Fourth 20% of population in 2005?
Offer a terse response. 31.42. What is the difference between the Income share held (as % of total income) in Second 20% of population in 1998 and the Income share held (as % of total income) in Third 20% of population in 2005?
Provide a short and direct response. -5.47. What is the difference between the Income share held (as % of total income) in Third 20% of population in 1998 and the Income share held (as % of total income) in Fourth 20% of population in 2005?
Give a very brief answer. -8.38. What is the difference between the Income share held (as % of total income) in First 20% of population in 1999 and the Income share held (as % of total income) in Second 20% of population in 2001?
Your answer should be very brief. 44. What is the difference between the Income share held (as % of total income) in First 20% of population in 1999 and the Income share held (as % of total income) in Fourth 20% of population in 2001?
Your answer should be compact. 31.08. What is the difference between the Income share held (as % of total income) of Second 20% of population in 1999 and the Income share held (as % of total income) of Third 20% of population in 2001?
Your answer should be compact. -5.02. What is the difference between the Income share held (as % of total income) of Second 20% of population in 1999 and the Income share held (as % of total income) of Fourth 20% of population in 2001?
Keep it short and to the point. -12.94. What is the difference between the Income share held (as % of total income) in Third 20% of population in 1999 and the Income share held (as % of total income) in Fourth 20% of population in 2001?
Your answer should be compact. -7.85. What is the difference between the Income share held (as % of total income) in First 20% of population in 1999 and the Income share held (as % of total income) in Second 20% of population in 2002?
Keep it short and to the point. 44.48. What is the difference between the Income share held (as % of total income) of First 20% of population in 1999 and the Income share held (as % of total income) of Third 20% of population in 2002?
Make the answer very short. 39.21. What is the difference between the Income share held (as % of total income) in First 20% of population in 1999 and the Income share held (as % of total income) in Fourth 20% of population in 2002?
Your answer should be very brief. 31.02. What is the difference between the Income share held (as % of total income) in Second 20% of population in 1999 and the Income share held (as % of total income) in Third 20% of population in 2002?
Your response must be concise. -4.81. What is the difference between the Income share held (as % of total income) of Second 20% of population in 1999 and the Income share held (as % of total income) of Fourth 20% of population in 2002?
Keep it short and to the point. -13. What is the difference between the Income share held (as % of total income) in Third 20% of population in 1999 and the Income share held (as % of total income) in Fourth 20% of population in 2002?
Your answer should be compact. -7.91. What is the difference between the Income share held (as % of total income) of First 20% of population in 1999 and the Income share held (as % of total income) of Second 20% of population in 2003?
Keep it short and to the point. 44.4. What is the difference between the Income share held (as % of total income) of First 20% of population in 1999 and the Income share held (as % of total income) of Third 20% of population in 2003?
Your answer should be compact. 38.83. What is the difference between the Income share held (as % of total income) of First 20% of population in 1999 and the Income share held (as % of total income) of Fourth 20% of population in 2003?
Make the answer very short. 30.44. What is the difference between the Income share held (as % of total income) in Second 20% of population in 1999 and the Income share held (as % of total income) in Third 20% of population in 2003?
Your response must be concise. -5.19. What is the difference between the Income share held (as % of total income) of Second 20% of population in 1999 and the Income share held (as % of total income) of Fourth 20% of population in 2003?
Give a very brief answer. -13.58. What is the difference between the Income share held (as % of total income) in Third 20% of population in 1999 and the Income share held (as % of total income) in Fourth 20% of population in 2003?
Your response must be concise. -8.49. What is the difference between the Income share held (as % of total income) in First 20% of population in 1999 and the Income share held (as % of total income) in Second 20% of population in 2004?
Keep it short and to the point. 44.23. What is the difference between the Income share held (as % of total income) in First 20% of population in 1999 and the Income share held (as % of total income) in Third 20% of population in 2004?
Offer a very short reply. 38.61. What is the difference between the Income share held (as % of total income) in First 20% of population in 1999 and the Income share held (as % of total income) in Fourth 20% of population in 2004?
Make the answer very short. 30.43. What is the difference between the Income share held (as % of total income) in Second 20% of population in 1999 and the Income share held (as % of total income) in Third 20% of population in 2004?
Provide a succinct answer. -5.41. What is the difference between the Income share held (as % of total income) of Second 20% of population in 1999 and the Income share held (as % of total income) of Fourth 20% of population in 2004?
Ensure brevity in your answer.  -13.59. What is the difference between the Income share held (as % of total income) in First 20% of population in 1999 and the Income share held (as % of total income) in Second 20% of population in 2005?
Give a very brief answer. 44.7. What is the difference between the Income share held (as % of total income) in First 20% of population in 1999 and the Income share held (as % of total income) in Third 20% of population in 2005?
Offer a very short reply. 38.93. What is the difference between the Income share held (as % of total income) in First 20% of population in 1999 and the Income share held (as % of total income) in Fourth 20% of population in 2005?
Your response must be concise. 30.6. What is the difference between the Income share held (as % of total income) in Second 20% of population in 1999 and the Income share held (as % of total income) in Third 20% of population in 2005?
Ensure brevity in your answer.  -5.09. What is the difference between the Income share held (as % of total income) in Second 20% of population in 1999 and the Income share held (as % of total income) in Fourth 20% of population in 2005?
Provide a short and direct response. -13.42. What is the difference between the Income share held (as % of total income) in Third 20% of population in 1999 and the Income share held (as % of total income) in Fourth 20% of population in 2005?
Make the answer very short. -8.33. What is the difference between the Income share held (as % of total income) of First 20% of population in 2001 and the Income share held (as % of total income) of Second 20% of population in 2002?
Offer a terse response. 44.35. What is the difference between the Income share held (as % of total income) of First 20% of population in 2001 and the Income share held (as % of total income) of Third 20% of population in 2002?
Provide a short and direct response. 39.08. What is the difference between the Income share held (as % of total income) in First 20% of population in 2001 and the Income share held (as % of total income) in Fourth 20% of population in 2002?
Your answer should be very brief. 30.89. What is the difference between the Income share held (as % of total income) in Second 20% of population in 2001 and the Income share held (as % of total income) in Third 20% of population in 2002?
Your response must be concise. -4.79. What is the difference between the Income share held (as % of total income) of Second 20% of population in 2001 and the Income share held (as % of total income) of Fourth 20% of population in 2002?
Your answer should be very brief. -12.98. What is the difference between the Income share held (as % of total income) in Third 20% of population in 2001 and the Income share held (as % of total income) in Fourth 20% of population in 2002?
Your answer should be compact. -7.98. What is the difference between the Income share held (as % of total income) in First 20% of population in 2001 and the Income share held (as % of total income) in Second 20% of population in 2003?
Offer a terse response. 44.27. What is the difference between the Income share held (as % of total income) of First 20% of population in 2001 and the Income share held (as % of total income) of Third 20% of population in 2003?
Provide a short and direct response. 38.7. What is the difference between the Income share held (as % of total income) of First 20% of population in 2001 and the Income share held (as % of total income) of Fourth 20% of population in 2003?
Make the answer very short. 30.31. What is the difference between the Income share held (as % of total income) in Second 20% of population in 2001 and the Income share held (as % of total income) in Third 20% of population in 2003?
Provide a short and direct response. -5.17. What is the difference between the Income share held (as % of total income) of Second 20% of population in 2001 and the Income share held (as % of total income) of Fourth 20% of population in 2003?
Keep it short and to the point. -13.56. What is the difference between the Income share held (as % of total income) of Third 20% of population in 2001 and the Income share held (as % of total income) of Fourth 20% of population in 2003?
Offer a terse response. -8.56. What is the difference between the Income share held (as % of total income) of First 20% of population in 2001 and the Income share held (as % of total income) of Second 20% of population in 2004?
Make the answer very short. 44.1. What is the difference between the Income share held (as % of total income) in First 20% of population in 2001 and the Income share held (as % of total income) in Third 20% of population in 2004?
Your answer should be very brief. 38.48. What is the difference between the Income share held (as % of total income) in First 20% of population in 2001 and the Income share held (as % of total income) in Fourth 20% of population in 2004?
Provide a short and direct response. 30.3. What is the difference between the Income share held (as % of total income) in Second 20% of population in 2001 and the Income share held (as % of total income) in Third 20% of population in 2004?
Offer a very short reply. -5.39. What is the difference between the Income share held (as % of total income) of Second 20% of population in 2001 and the Income share held (as % of total income) of Fourth 20% of population in 2004?
Offer a terse response. -13.57. What is the difference between the Income share held (as % of total income) of Third 20% of population in 2001 and the Income share held (as % of total income) of Fourth 20% of population in 2004?
Make the answer very short. -8.57. What is the difference between the Income share held (as % of total income) in First 20% of population in 2001 and the Income share held (as % of total income) in Second 20% of population in 2005?
Make the answer very short. 44.57. What is the difference between the Income share held (as % of total income) of First 20% of population in 2001 and the Income share held (as % of total income) of Third 20% of population in 2005?
Offer a very short reply. 38.8. What is the difference between the Income share held (as % of total income) in First 20% of population in 2001 and the Income share held (as % of total income) in Fourth 20% of population in 2005?
Make the answer very short. 30.47. What is the difference between the Income share held (as % of total income) of Second 20% of population in 2001 and the Income share held (as % of total income) of Third 20% of population in 2005?
Ensure brevity in your answer.  -5.07. What is the difference between the Income share held (as % of total income) of First 20% of population in 2002 and the Income share held (as % of total income) of Second 20% of population in 2003?
Your answer should be compact. 45.79. What is the difference between the Income share held (as % of total income) of First 20% of population in 2002 and the Income share held (as % of total income) of Third 20% of population in 2003?
Offer a terse response. 40.22. What is the difference between the Income share held (as % of total income) of First 20% of population in 2002 and the Income share held (as % of total income) of Fourth 20% of population in 2003?
Give a very brief answer. 31.83. What is the difference between the Income share held (as % of total income) in Second 20% of population in 2002 and the Income share held (as % of total income) in Third 20% of population in 2003?
Offer a terse response. -5.65. What is the difference between the Income share held (as % of total income) in Second 20% of population in 2002 and the Income share held (as % of total income) in Fourth 20% of population in 2003?
Ensure brevity in your answer.  -14.04. What is the difference between the Income share held (as % of total income) in Third 20% of population in 2002 and the Income share held (as % of total income) in Fourth 20% of population in 2003?
Give a very brief answer. -8.77. What is the difference between the Income share held (as % of total income) of First 20% of population in 2002 and the Income share held (as % of total income) of Second 20% of population in 2004?
Provide a succinct answer. 45.62. What is the difference between the Income share held (as % of total income) of First 20% of population in 2002 and the Income share held (as % of total income) of Fourth 20% of population in 2004?
Provide a short and direct response. 31.82. What is the difference between the Income share held (as % of total income) of Second 20% of population in 2002 and the Income share held (as % of total income) of Third 20% of population in 2004?
Give a very brief answer. -5.87. What is the difference between the Income share held (as % of total income) of Second 20% of population in 2002 and the Income share held (as % of total income) of Fourth 20% of population in 2004?
Ensure brevity in your answer.  -14.05. What is the difference between the Income share held (as % of total income) of Third 20% of population in 2002 and the Income share held (as % of total income) of Fourth 20% of population in 2004?
Provide a short and direct response. -8.78. What is the difference between the Income share held (as % of total income) in First 20% of population in 2002 and the Income share held (as % of total income) in Second 20% of population in 2005?
Provide a succinct answer. 46.09. What is the difference between the Income share held (as % of total income) in First 20% of population in 2002 and the Income share held (as % of total income) in Third 20% of population in 2005?
Provide a succinct answer. 40.32. What is the difference between the Income share held (as % of total income) of First 20% of population in 2002 and the Income share held (as % of total income) of Fourth 20% of population in 2005?
Offer a very short reply. 31.99. What is the difference between the Income share held (as % of total income) of Second 20% of population in 2002 and the Income share held (as % of total income) of Third 20% of population in 2005?
Make the answer very short. -5.55. What is the difference between the Income share held (as % of total income) in Second 20% of population in 2002 and the Income share held (as % of total income) in Fourth 20% of population in 2005?
Keep it short and to the point. -13.88. What is the difference between the Income share held (as % of total income) in Third 20% of population in 2002 and the Income share held (as % of total income) in Fourth 20% of population in 2005?
Your answer should be very brief. -8.61. What is the difference between the Income share held (as % of total income) in First 20% of population in 2003 and the Income share held (as % of total income) in Second 20% of population in 2004?
Provide a succinct answer. 44.95. What is the difference between the Income share held (as % of total income) of First 20% of population in 2003 and the Income share held (as % of total income) of Third 20% of population in 2004?
Your answer should be compact. 39.33. What is the difference between the Income share held (as % of total income) in First 20% of population in 2003 and the Income share held (as % of total income) in Fourth 20% of population in 2004?
Your response must be concise. 31.15. What is the difference between the Income share held (as % of total income) of Second 20% of population in 2003 and the Income share held (as % of total income) of Third 20% of population in 2004?
Provide a short and direct response. -5.79. What is the difference between the Income share held (as % of total income) in Second 20% of population in 2003 and the Income share held (as % of total income) in Fourth 20% of population in 2004?
Provide a succinct answer. -13.97. What is the difference between the Income share held (as % of total income) of First 20% of population in 2003 and the Income share held (as % of total income) of Second 20% of population in 2005?
Your response must be concise. 45.42. What is the difference between the Income share held (as % of total income) in First 20% of population in 2003 and the Income share held (as % of total income) in Third 20% of population in 2005?
Keep it short and to the point. 39.65. What is the difference between the Income share held (as % of total income) in First 20% of population in 2003 and the Income share held (as % of total income) in Fourth 20% of population in 2005?
Your answer should be very brief. 31.32. What is the difference between the Income share held (as % of total income) of Second 20% of population in 2003 and the Income share held (as % of total income) of Third 20% of population in 2005?
Offer a terse response. -5.47. What is the difference between the Income share held (as % of total income) in Third 20% of population in 2003 and the Income share held (as % of total income) in Fourth 20% of population in 2005?
Offer a very short reply. -8.23. What is the difference between the Income share held (as % of total income) in First 20% of population in 2004 and the Income share held (as % of total income) in Second 20% of population in 2005?
Ensure brevity in your answer.  44.95. What is the difference between the Income share held (as % of total income) of First 20% of population in 2004 and the Income share held (as % of total income) of Third 20% of population in 2005?
Provide a succinct answer. 39.18. What is the difference between the Income share held (as % of total income) of First 20% of population in 2004 and the Income share held (as % of total income) of Fourth 20% of population in 2005?
Offer a terse response. 30.85. What is the difference between the Income share held (as % of total income) of Second 20% of population in 2004 and the Income share held (as % of total income) of Fourth 20% of population in 2005?
Offer a terse response. -13.63. What is the difference between the Income share held (as % of total income) of Third 20% of population in 2004 and the Income share held (as % of total income) of Fourth 20% of population in 2005?
Your response must be concise. -8.01. What is the average Income share held (as % of total income) of First 20% of population per year?
Give a very brief answer. 52.67. What is the average Income share held (as % of total income) in Second 20% of population per year?
Your answer should be compact. 8.6. What is the average Income share held (as % of total income) of Third 20% of population per year?
Offer a very short reply. 13.9. What is the average Income share held (as % of total income) in Fourth 20% of population per year?
Make the answer very short. 21.82. In the year 1992, what is the difference between the Income share held (as % of total income) of First 20% of population and Income share held (as % of total income) of Second 20% of population?
Your response must be concise. 37.78. In the year 1992, what is the difference between the Income share held (as % of total income) of First 20% of population and Income share held (as % of total income) of Third 20% of population?
Give a very brief answer. 32.92. In the year 1992, what is the difference between the Income share held (as % of total income) in First 20% of population and Income share held (as % of total income) in Fourth 20% of population?
Keep it short and to the point. 25.91. In the year 1992, what is the difference between the Income share held (as % of total income) in Second 20% of population and Income share held (as % of total income) in Third 20% of population?
Provide a short and direct response. -4.86. In the year 1992, what is the difference between the Income share held (as % of total income) of Second 20% of population and Income share held (as % of total income) of Fourth 20% of population?
Keep it short and to the point. -11.87. In the year 1992, what is the difference between the Income share held (as % of total income) of Third 20% of population and Income share held (as % of total income) of Fourth 20% of population?
Offer a terse response. -7.01. In the year 1995, what is the difference between the Income share held (as % of total income) in First 20% of population and Income share held (as % of total income) in Second 20% of population?
Your response must be concise. 43.6. In the year 1995, what is the difference between the Income share held (as % of total income) in First 20% of population and Income share held (as % of total income) in Third 20% of population?
Keep it short and to the point. 38.51. In the year 1995, what is the difference between the Income share held (as % of total income) in First 20% of population and Income share held (as % of total income) in Fourth 20% of population?
Ensure brevity in your answer.  30.79. In the year 1995, what is the difference between the Income share held (as % of total income) of Second 20% of population and Income share held (as % of total income) of Third 20% of population?
Keep it short and to the point. -5.09. In the year 1995, what is the difference between the Income share held (as % of total income) of Second 20% of population and Income share held (as % of total income) of Fourth 20% of population?
Provide a succinct answer. -12.81. In the year 1995, what is the difference between the Income share held (as % of total income) in Third 20% of population and Income share held (as % of total income) in Fourth 20% of population?
Your answer should be compact. -7.72. In the year 1998, what is the difference between the Income share held (as % of total income) in First 20% of population and Income share held (as % of total income) in Second 20% of population?
Offer a terse response. 45.22. In the year 1998, what is the difference between the Income share held (as % of total income) in First 20% of population and Income share held (as % of total income) in Third 20% of population?
Provide a short and direct response. 39.8. In the year 1998, what is the difference between the Income share held (as % of total income) of First 20% of population and Income share held (as % of total income) of Fourth 20% of population?
Ensure brevity in your answer.  31.84. In the year 1998, what is the difference between the Income share held (as % of total income) of Second 20% of population and Income share held (as % of total income) of Third 20% of population?
Offer a terse response. -5.42. In the year 1998, what is the difference between the Income share held (as % of total income) in Second 20% of population and Income share held (as % of total income) in Fourth 20% of population?
Offer a very short reply. -13.38. In the year 1998, what is the difference between the Income share held (as % of total income) of Third 20% of population and Income share held (as % of total income) of Fourth 20% of population?
Offer a terse response. -7.96. In the year 1999, what is the difference between the Income share held (as % of total income) of First 20% of population and Income share held (as % of total income) of Second 20% of population?
Provide a succinct answer. 44.02. In the year 1999, what is the difference between the Income share held (as % of total income) of First 20% of population and Income share held (as % of total income) of Third 20% of population?
Offer a terse response. 38.93. In the year 1999, what is the difference between the Income share held (as % of total income) in First 20% of population and Income share held (as % of total income) in Fourth 20% of population?
Offer a terse response. 31.31. In the year 1999, what is the difference between the Income share held (as % of total income) of Second 20% of population and Income share held (as % of total income) of Third 20% of population?
Provide a succinct answer. -5.09. In the year 1999, what is the difference between the Income share held (as % of total income) in Second 20% of population and Income share held (as % of total income) in Fourth 20% of population?
Ensure brevity in your answer.  -12.71. In the year 1999, what is the difference between the Income share held (as % of total income) in Third 20% of population and Income share held (as % of total income) in Fourth 20% of population?
Offer a terse response. -7.62. In the year 2001, what is the difference between the Income share held (as % of total income) in First 20% of population and Income share held (as % of total income) in Second 20% of population?
Ensure brevity in your answer.  43.87. In the year 2001, what is the difference between the Income share held (as % of total income) in First 20% of population and Income share held (as % of total income) in Third 20% of population?
Offer a terse response. 38.87. In the year 2001, what is the difference between the Income share held (as % of total income) of First 20% of population and Income share held (as % of total income) of Fourth 20% of population?
Keep it short and to the point. 30.95. In the year 2001, what is the difference between the Income share held (as % of total income) in Second 20% of population and Income share held (as % of total income) in Fourth 20% of population?
Offer a very short reply. -12.92. In the year 2001, what is the difference between the Income share held (as % of total income) in Third 20% of population and Income share held (as % of total income) in Fourth 20% of population?
Your answer should be compact. -7.92. In the year 2002, what is the difference between the Income share held (as % of total income) of First 20% of population and Income share held (as % of total income) of Second 20% of population?
Provide a short and direct response. 45.87. In the year 2002, what is the difference between the Income share held (as % of total income) of First 20% of population and Income share held (as % of total income) of Third 20% of population?
Keep it short and to the point. 40.6. In the year 2002, what is the difference between the Income share held (as % of total income) of First 20% of population and Income share held (as % of total income) of Fourth 20% of population?
Your answer should be compact. 32.41. In the year 2002, what is the difference between the Income share held (as % of total income) in Second 20% of population and Income share held (as % of total income) in Third 20% of population?
Your answer should be compact. -5.27. In the year 2002, what is the difference between the Income share held (as % of total income) in Second 20% of population and Income share held (as % of total income) in Fourth 20% of population?
Keep it short and to the point. -13.46. In the year 2002, what is the difference between the Income share held (as % of total income) in Third 20% of population and Income share held (as % of total income) in Fourth 20% of population?
Your answer should be very brief. -8.19. In the year 2003, what is the difference between the Income share held (as % of total income) of First 20% of population and Income share held (as % of total income) of Second 20% of population?
Your answer should be compact. 45.12. In the year 2003, what is the difference between the Income share held (as % of total income) of First 20% of population and Income share held (as % of total income) of Third 20% of population?
Give a very brief answer. 39.55. In the year 2003, what is the difference between the Income share held (as % of total income) of First 20% of population and Income share held (as % of total income) of Fourth 20% of population?
Your answer should be very brief. 31.16. In the year 2003, what is the difference between the Income share held (as % of total income) of Second 20% of population and Income share held (as % of total income) of Third 20% of population?
Your answer should be compact. -5.57. In the year 2003, what is the difference between the Income share held (as % of total income) in Second 20% of population and Income share held (as % of total income) in Fourth 20% of population?
Provide a succinct answer. -13.96. In the year 2003, what is the difference between the Income share held (as % of total income) of Third 20% of population and Income share held (as % of total income) of Fourth 20% of population?
Provide a short and direct response. -8.39. In the year 2004, what is the difference between the Income share held (as % of total income) of First 20% of population and Income share held (as % of total income) of Second 20% of population?
Keep it short and to the point. 44.48. In the year 2004, what is the difference between the Income share held (as % of total income) in First 20% of population and Income share held (as % of total income) in Third 20% of population?
Your answer should be very brief. 38.86. In the year 2004, what is the difference between the Income share held (as % of total income) of First 20% of population and Income share held (as % of total income) of Fourth 20% of population?
Make the answer very short. 30.68. In the year 2004, what is the difference between the Income share held (as % of total income) of Second 20% of population and Income share held (as % of total income) of Third 20% of population?
Make the answer very short. -5.62. In the year 2004, what is the difference between the Income share held (as % of total income) in Second 20% of population and Income share held (as % of total income) in Fourth 20% of population?
Make the answer very short. -13.8. In the year 2004, what is the difference between the Income share held (as % of total income) of Third 20% of population and Income share held (as % of total income) of Fourth 20% of population?
Your answer should be very brief. -8.18. In the year 2005, what is the difference between the Income share held (as % of total income) in First 20% of population and Income share held (as % of total income) in Second 20% of population?
Your answer should be compact. 46.66. In the year 2005, what is the difference between the Income share held (as % of total income) of First 20% of population and Income share held (as % of total income) of Third 20% of population?
Give a very brief answer. 40.89. In the year 2005, what is the difference between the Income share held (as % of total income) of First 20% of population and Income share held (as % of total income) of Fourth 20% of population?
Provide a short and direct response. 32.56. In the year 2005, what is the difference between the Income share held (as % of total income) in Second 20% of population and Income share held (as % of total income) in Third 20% of population?
Ensure brevity in your answer.  -5.77. In the year 2005, what is the difference between the Income share held (as % of total income) of Second 20% of population and Income share held (as % of total income) of Fourth 20% of population?
Make the answer very short. -14.1. In the year 2005, what is the difference between the Income share held (as % of total income) in Third 20% of population and Income share held (as % of total income) in Fourth 20% of population?
Make the answer very short. -8.33. What is the ratio of the Income share held (as % of total income) of First 20% of population in 1992 to that in 1995?
Keep it short and to the point. 0.92. What is the ratio of the Income share held (as % of total income) in Second 20% of population in 1992 to that in 1995?
Keep it short and to the point. 1.17. What is the ratio of the Income share held (as % of total income) of Third 20% of population in 1992 to that in 1995?
Give a very brief answer. 1.09. What is the ratio of the Income share held (as % of total income) of Fourth 20% of population in 1992 to that in 1995?
Provide a succinct answer. 1.03. What is the ratio of the Income share held (as % of total income) of First 20% of population in 1992 to that in 1998?
Provide a short and direct response. 0.9. What is the ratio of the Income share held (as % of total income) of Second 20% of population in 1992 to that in 1998?
Your answer should be very brief. 1.23. What is the ratio of the Income share held (as % of total income) in Third 20% of population in 1992 to that in 1998?
Offer a terse response. 1.1. What is the ratio of the Income share held (as % of total income) in Fourth 20% of population in 1992 to that in 1998?
Give a very brief answer. 1.02. What is the ratio of the Income share held (as % of total income) in First 20% of population in 1992 to that in 1999?
Offer a terse response. 0.91. What is the ratio of the Income share held (as % of total income) of Second 20% of population in 1992 to that in 1999?
Offer a very short reply. 1.17. What is the ratio of the Income share held (as % of total income) of Third 20% of population in 1992 to that in 1999?
Give a very brief answer. 1.09. What is the ratio of the Income share held (as % of total income) in Fourth 20% of population in 1992 to that in 1999?
Make the answer very short. 1.03. What is the ratio of the Income share held (as % of total income) in First 20% of population in 1992 to that in 2001?
Keep it short and to the point. 0.91. What is the ratio of the Income share held (as % of total income) of Second 20% of population in 1992 to that in 2001?
Provide a succinct answer. 1.17. What is the ratio of the Income share held (as % of total income) in Third 20% of population in 1992 to that in 2001?
Provide a succinct answer. 1.1. What is the ratio of the Income share held (as % of total income) in Fourth 20% of population in 1992 to that in 2001?
Provide a short and direct response. 1.02. What is the ratio of the Income share held (as % of total income) of First 20% of population in 1992 to that in 2002?
Provide a succinct answer. 0.89. What is the ratio of the Income share held (as % of total income) in Second 20% of population in 1992 to that in 2002?
Provide a succinct answer. 1.24. What is the ratio of the Income share held (as % of total income) of Third 20% of population in 1992 to that in 2002?
Provide a short and direct response. 1.12. What is the ratio of the Income share held (as % of total income) in Fourth 20% of population in 1992 to that in 2002?
Your answer should be very brief. 1.02. What is the ratio of the Income share held (as % of total income) of First 20% of population in 1992 to that in 2003?
Offer a terse response. 0.9. What is the ratio of the Income share held (as % of total income) of Second 20% of population in 1992 to that in 2003?
Make the answer very short. 1.23. What is the ratio of the Income share held (as % of total income) in Third 20% of population in 1992 to that in 2003?
Provide a succinct answer. 1.09. What is the ratio of the Income share held (as % of total income) in First 20% of population in 1992 to that in 2004?
Give a very brief answer. 0.91. What is the ratio of the Income share held (as % of total income) in Second 20% of population in 1992 to that in 2004?
Provide a short and direct response. 1.2. What is the ratio of the Income share held (as % of total income) in Third 20% of population in 1992 to that in 2004?
Make the answer very short. 1.07. What is the ratio of the Income share held (as % of total income) of Fourth 20% of population in 1992 to that in 2004?
Offer a terse response. 0.99. What is the ratio of the Income share held (as % of total income) in First 20% of population in 1992 to that in 2005?
Make the answer very short. 0.88. What is the ratio of the Income share held (as % of total income) of Second 20% of population in 1992 to that in 2005?
Offer a terse response. 1.27. What is the ratio of the Income share held (as % of total income) in Third 20% of population in 1992 to that in 2005?
Your answer should be compact. 1.09. What is the ratio of the Income share held (as % of total income) in Fourth 20% of population in 1992 to that in 2005?
Keep it short and to the point. 1. What is the ratio of the Income share held (as % of total income) of First 20% of population in 1995 to that in 1998?
Keep it short and to the point. 0.98. What is the ratio of the Income share held (as % of total income) of Second 20% of population in 1995 to that in 1998?
Keep it short and to the point. 1.05. What is the ratio of the Income share held (as % of total income) of Third 20% of population in 1995 to that in 1998?
Keep it short and to the point. 1.01. What is the ratio of the Income share held (as % of total income) of Second 20% of population in 1995 to that in 1999?
Your answer should be very brief. 1. What is the ratio of the Income share held (as % of total income) in Fourth 20% of population in 1995 to that in 1999?
Offer a terse response. 1.01. What is the ratio of the Income share held (as % of total income) in Third 20% of population in 1995 to that in 2001?
Offer a terse response. 1.01. What is the ratio of the Income share held (as % of total income) in First 20% of population in 1995 to that in 2002?
Provide a short and direct response. 0.97. What is the ratio of the Income share held (as % of total income) in Second 20% of population in 1995 to that in 2002?
Give a very brief answer. 1.06. What is the ratio of the Income share held (as % of total income) of Third 20% of population in 1995 to that in 2002?
Keep it short and to the point. 1.02. What is the ratio of the Income share held (as % of total income) of Fourth 20% of population in 1995 to that in 2002?
Give a very brief answer. 0.99. What is the ratio of the Income share held (as % of total income) of First 20% of population in 1995 to that in 2003?
Give a very brief answer. 0.98. What is the ratio of the Income share held (as % of total income) in Second 20% of population in 1995 to that in 2003?
Your response must be concise. 1.05. What is the ratio of the Income share held (as % of total income) in Fourth 20% of population in 1995 to that in 2003?
Give a very brief answer. 0.97. What is the ratio of the Income share held (as % of total income) of Second 20% of population in 1995 to that in 2004?
Your response must be concise. 1.03. What is the ratio of the Income share held (as % of total income) in Third 20% of population in 1995 to that in 2004?
Offer a very short reply. 0.98. What is the ratio of the Income share held (as % of total income) of Fourth 20% of population in 1995 to that in 2004?
Offer a terse response. 0.97. What is the ratio of the Income share held (as % of total income) of First 20% of population in 1995 to that in 2005?
Offer a very short reply. 0.96. What is the ratio of the Income share held (as % of total income) of Second 20% of population in 1995 to that in 2005?
Offer a terse response. 1.09. What is the ratio of the Income share held (as % of total income) in Fourth 20% of population in 1995 to that in 2005?
Your answer should be very brief. 0.97. What is the ratio of the Income share held (as % of total income) of First 20% of population in 1998 to that in 1999?
Make the answer very short. 1.02. What is the ratio of the Income share held (as % of total income) in Second 20% of population in 1998 to that in 1999?
Offer a very short reply. 0.96. What is the ratio of the Income share held (as % of total income) in Third 20% of population in 1998 to that in 1999?
Make the answer very short. 1. What is the ratio of the Income share held (as % of total income) in Fourth 20% of population in 1998 to that in 1999?
Give a very brief answer. 1.01. What is the ratio of the Income share held (as % of total income) of First 20% of population in 1998 to that in 2001?
Your answer should be compact. 1.02. What is the ratio of the Income share held (as % of total income) in Second 20% of population in 1998 to that in 2001?
Provide a short and direct response. 0.95. What is the ratio of the Income share held (as % of total income) in Fourth 20% of population in 1998 to that in 2001?
Your response must be concise. 1. What is the ratio of the Income share held (as % of total income) of First 20% of population in 1998 to that in 2002?
Provide a succinct answer. 0.99. What is the ratio of the Income share held (as % of total income) in Second 20% of population in 1998 to that in 2002?
Your answer should be very brief. 1.01. What is the ratio of the Income share held (as % of total income) of Third 20% of population in 1998 to that in 2002?
Keep it short and to the point. 1.02. What is the ratio of the Income share held (as % of total income) in First 20% of population in 1998 to that in 2003?
Give a very brief answer. 1. What is the ratio of the Income share held (as % of total income) of Second 20% of population in 1998 to that in 2003?
Keep it short and to the point. 1. What is the ratio of the Income share held (as % of total income) in Third 20% of population in 1998 to that in 2003?
Offer a very short reply. 0.99. What is the ratio of the Income share held (as % of total income) of Fourth 20% of population in 1998 to that in 2003?
Your answer should be very brief. 0.97. What is the ratio of the Income share held (as % of total income) in First 20% of population in 1998 to that in 2004?
Provide a succinct answer. 1.01. What is the ratio of the Income share held (as % of total income) in Second 20% of population in 1998 to that in 2004?
Offer a terse response. 0.98. What is the ratio of the Income share held (as % of total income) of Third 20% of population in 1998 to that in 2004?
Offer a terse response. 0.97. What is the ratio of the Income share held (as % of total income) in Fourth 20% of population in 1998 to that in 2004?
Make the answer very short. 0.97. What is the ratio of the Income share held (as % of total income) of First 20% of population in 1998 to that in 2005?
Make the answer very short. 0.98. What is the ratio of the Income share held (as % of total income) in Second 20% of population in 1998 to that in 2005?
Offer a terse response. 1.04. What is the ratio of the Income share held (as % of total income) in Third 20% of population in 1998 to that in 2005?
Make the answer very short. 1. What is the ratio of the Income share held (as % of total income) in Fourth 20% of population in 1998 to that in 2005?
Offer a very short reply. 0.98. What is the ratio of the Income share held (as % of total income) in Third 20% of population in 1999 to that in 2001?
Provide a succinct answer. 1.01. What is the ratio of the Income share held (as % of total income) of Fourth 20% of population in 1999 to that in 2001?
Ensure brevity in your answer.  0.99. What is the ratio of the Income share held (as % of total income) in First 20% of population in 1999 to that in 2002?
Keep it short and to the point. 0.97. What is the ratio of the Income share held (as % of total income) in Second 20% of population in 1999 to that in 2002?
Offer a terse response. 1.06. What is the ratio of the Income share held (as % of total income) of Third 20% of population in 1999 to that in 2002?
Give a very brief answer. 1.02. What is the ratio of the Income share held (as % of total income) of Fourth 20% of population in 1999 to that in 2002?
Provide a succinct answer. 0.99. What is the ratio of the Income share held (as % of total income) of First 20% of population in 1999 to that in 2003?
Your answer should be compact. 0.99. What is the ratio of the Income share held (as % of total income) in Second 20% of population in 1999 to that in 2003?
Keep it short and to the point. 1.05. What is the ratio of the Income share held (as % of total income) of Third 20% of population in 1999 to that in 2003?
Make the answer very short. 0.99. What is the ratio of the Income share held (as % of total income) of Fourth 20% of population in 1999 to that in 2003?
Offer a very short reply. 0.96. What is the ratio of the Income share held (as % of total income) in Second 20% of population in 1999 to that in 2004?
Keep it short and to the point. 1.02. What is the ratio of the Income share held (as % of total income) in Third 20% of population in 1999 to that in 2004?
Provide a succinct answer. 0.98. What is the ratio of the Income share held (as % of total income) of Fourth 20% of population in 1999 to that in 2004?
Offer a very short reply. 0.96. What is the ratio of the Income share held (as % of total income) of First 20% of population in 1999 to that in 2005?
Provide a short and direct response. 0.96. What is the ratio of the Income share held (as % of total income) of Second 20% of population in 1999 to that in 2005?
Your answer should be compact. 1.09. What is the ratio of the Income share held (as % of total income) in Third 20% of population in 1999 to that in 2005?
Offer a very short reply. 1. What is the ratio of the Income share held (as % of total income) in Fourth 20% of population in 1999 to that in 2005?
Your answer should be compact. 0.97. What is the ratio of the Income share held (as % of total income) in First 20% of population in 2001 to that in 2002?
Offer a very short reply. 0.97. What is the ratio of the Income share held (as % of total income) of Second 20% of population in 2001 to that in 2002?
Make the answer very short. 1.06. What is the ratio of the Income share held (as % of total income) of Third 20% of population in 2001 to that in 2002?
Offer a terse response. 1.02. What is the ratio of the Income share held (as % of total income) of Fourth 20% of population in 2001 to that in 2002?
Make the answer very short. 1. What is the ratio of the Income share held (as % of total income) of First 20% of population in 2001 to that in 2003?
Ensure brevity in your answer.  0.98. What is the ratio of the Income share held (as % of total income) of Second 20% of population in 2001 to that in 2003?
Your response must be concise. 1.05. What is the ratio of the Income share held (as % of total income) in Third 20% of population in 2001 to that in 2003?
Make the answer very short. 0.99. What is the ratio of the Income share held (as % of total income) in Fourth 20% of population in 2001 to that in 2003?
Make the answer very short. 0.97. What is the ratio of the Income share held (as % of total income) of Second 20% of population in 2001 to that in 2004?
Give a very brief answer. 1.03. What is the ratio of the Income share held (as % of total income) in Third 20% of population in 2001 to that in 2004?
Your response must be concise. 0.97. What is the ratio of the Income share held (as % of total income) of Fourth 20% of population in 2001 to that in 2004?
Offer a terse response. 0.97. What is the ratio of the Income share held (as % of total income) in First 20% of population in 2001 to that in 2005?
Make the answer very short. 0.96. What is the ratio of the Income share held (as % of total income) of Second 20% of population in 2001 to that in 2005?
Your response must be concise. 1.09. What is the ratio of the Income share held (as % of total income) in Fourth 20% of population in 2001 to that in 2005?
Provide a short and direct response. 0.98. What is the ratio of the Income share held (as % of total income) in First 20% of population in 2002 to that in 2003?
Provide a succinct answer. 1.01. What is the ratio of the Income share held (as % of total income) in Second 20% of population in 2002 to that in 2003?
Offer a very short reply. 0.99. What is the ratio of the Income share held (as % of total income) in Third 20% of population in 2002 to that in 2003?
Offer a very short reply. 0.97. What is the ratio of the Income share held (as % of total income) in Fourth 20% of population in 2002 to that in 2003?
Your answer should be very brief. 0.97. What is the ratio of the Income share held (as % of total income) of First 20% of population in 2002 to that in 2004?
Make the answer very short. 1.02. What is the ratio of the Income share held (as % of total income) in Second 20% of population in 2002 to that in 2004?
Keep it short and to the point. 0.97. What is the ratio of the Income share held (as % of total income) of Third 20% of population in 2002 to that in 2004?
Offer a terse response. 0.96. What is the ratio of the Income share held (as % of total income) in Fourth 20% of population in 2002 to that in 2004?
Make the answer very short. 0.97. What is the ratio of the Income share held (as % of total income) in First 20% of population in 2002 to that in 2005?
Your answer should be very brief. 0.99. What is the ratio of the Income share held (as % of total income) of Second 20% of population in 2002 to that in 2005?
Provide a short and direct response. 1.03. What is the ratio of the Income share held (as % of total income) in Third 20% of population in 2002 to that in 2005?
Your response must be concise. 0.98. What is the ratio of the Income share held (as % of total income) of Fourth 20% of population in 2002 to that in 2005?
Make the answer very short. 0.98. What is the ratio of the Income share held (as % of total income) in First 20% of population in 2003 to that in 2004?
Keep it short and to the point. 1.01. What is the ratio of the Income share held (as % of total income) in Second 20% of population in 2003 to that in 2004?
Provide a succinct answer. 0.98. What is the ratio of the Income share held (as % of total income) of Third 20% of population in 2003 to that in 2004?
Your answer should be compact. 0.98. What is the ratio of the Income share held (as % of total income) in First 20% of population in 2003 to that in 2005?
Your answer should be very brief. 0.98. What is the ratio of the Income share held (as % of total income) of Second 20% of population in 2003 to that in 2005?
Provide a short and direct response. 1.04. What is the ratio of the Income share held (as % of total income) of Third 20% of population in 2003 to that in 2005?
Keep it short and to the point. 1.01. What is the ratio of the Income share held (as % of total income) of Fourth 20% of population in 2003 to that in 2005?
Your answer should be very brief. 1.01. What is the ratio of the Income share held (as % of total income) in First 20% of population in 2004 to that in 2005?
Provide a short and direct response. 0.97. What is the ratio of the Income share held (as % of total income) in Second 20% of population in 2004 to that in 2005?
Offer a very short reply. 1.06. What is the ratio of the Income share held (as % of total income) of Third 20% of population in 2004 to that in 2005?
Provide a succinct answer. 1.02. What is the ratio of the Income share held (as % of total income) of Fourth 20% of population in 2004 to that in 2005?
Your response must be concise. 1.01. What is the difference between the highest and the second highest Income share held (as % of total income) in First 20% of population?
Offer a very short reply. 0.57. What is the difference between the highest and the second highest Income share held (as % of total income) of Second 20% of population?
Your response must be concise. 1.49. What is the difference between the highest and the second highest Income share held (as % of total income) of Third 20% of population?
Give a very brief answer. 0.96. What is the difference between the highest and the second highest Income share held (as % of total income) of Fourth 20% of population?
Offer a terse response. 0.01. What is the difference between the highest and the lowest Income share held (as % of total income) of First 20% of population?
Your response must be concise. 6.69. What is the difference between the highest and the lowest Income share held (as % of total income) of Second 20% of population?
Your response must be concise. 2.19. What is the difference between the highest and the lowest Income share held (as % of total income) in Third 20% of population?
Offer a terse response. 1.56. 